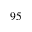Convert formula to latex. <formula><loc_0><loc_0><loc_500><loc_500>9 5</formula> 